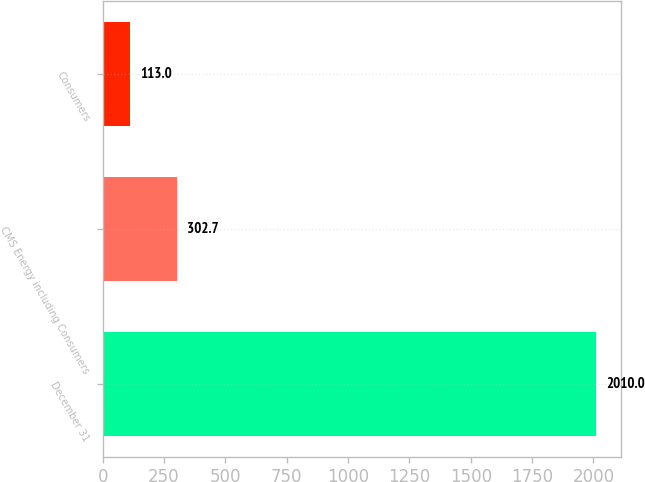Convert chart to OTSL. <chart><loc_0><loc_0><loc_500><loc_500><bar_chart><fcel>December 31<fcel>CMS Energy including Consumers<fcel>Consumers<nl><fcel>2010<fcel>302.7<fcel>113<nl></chart> 